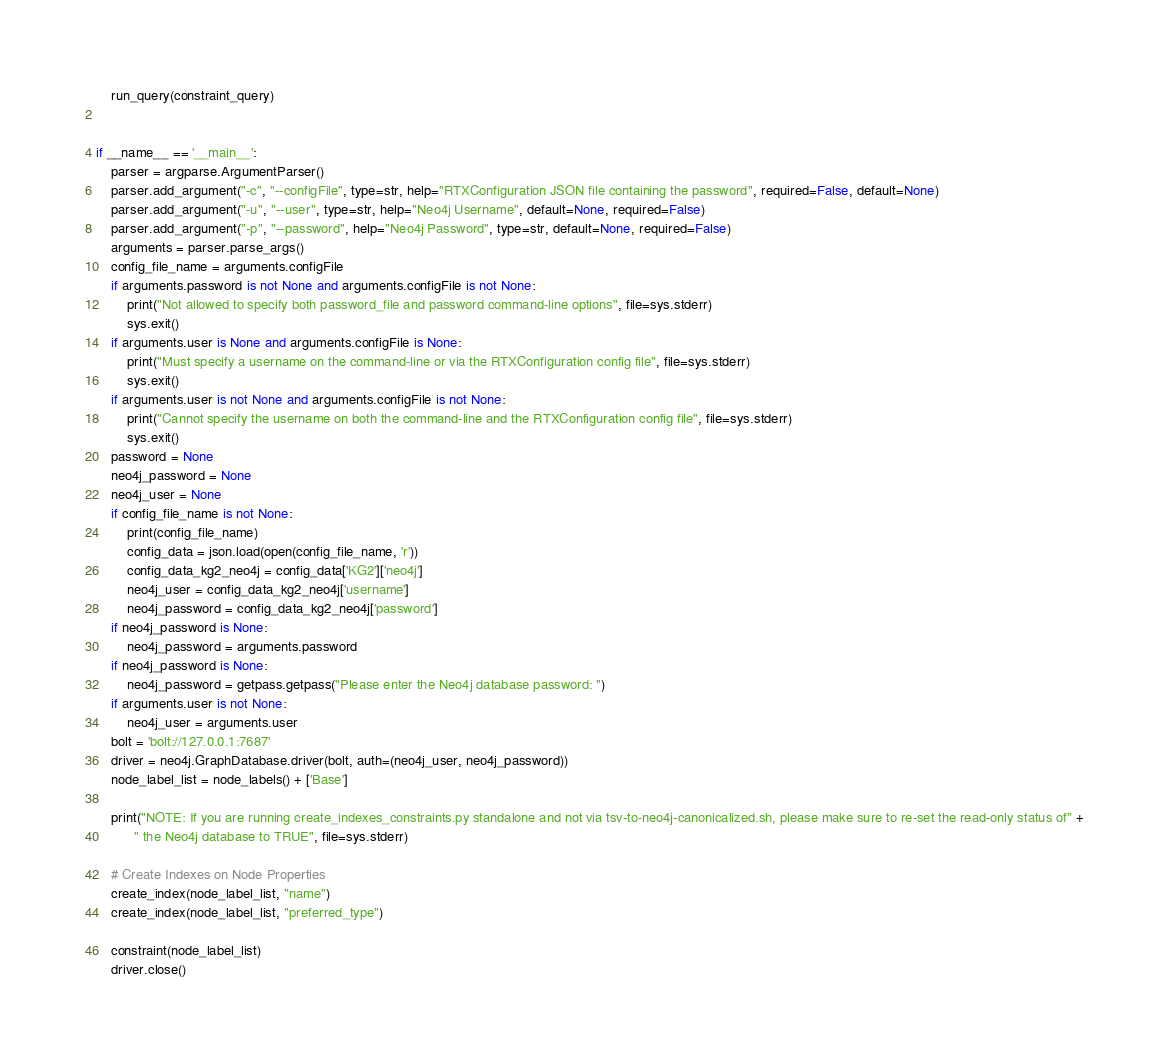<code> <loc_0><loc_0><loc_500><loc_500><_Python_>    run_query(constraint_query)


if __name__ == '__main__':
    parser = argparse.ArgumentParser()
    parser.add_argument("-c", "--configFile", type=str, help="RTXConfiguration JSON file containing the password", required=False, default=None)
    parser.add_argument("-u", "--user", type=str, help="Neo4j Username", default=None, required=False)
    parser.add_argument("-p", "--password", help="Neo4j Password", type=str, default=None, required=False)
    arguments = parser.parse_args()
    config_file_name = arguments.configFile
    if arguments.password is not None and arguments.configFile is not None:
        print("Not allowed to specify both password_file and password command-line options", file=sys.stderr)
        sys.exit()
    if arguments.user is None and arguments.configFile is None:
        print("Must specify a username on the command-line or via the RTXConfiguration config file", file=sys.stderr)
        sys.exit()
    if arguments.user is not None and arguments.configFile is not None:
        print("Cannot specify the username on both the command-line and the RTXConfiguration config file", file=sys.stderr)
        sys.exit()
    password = None
    neo4j_password = None
    neo4j_user = None
    if config_file_name is not None:
        print(config_file_name)
        config_data = json.load(open(config_file_name, 'r'))
        config_data_kg2_neo4j = config_data['KG2']['neo4j']
        neo4j_user = config_data_kg2_neo4j['username']
        neo4j_password = config_data_kg2_neo4j['password']
    if neo4j_password is None:
        neo4j_password = arguments.password
    if neo4j_password is None:
        neo4j_password = getpass.getpass("Please enter the Neo4j database password: ")
    if arguments.user is not None:
        neo4j_user = arguments.user
    bolt = 'bolt://127.0.0.1:7687'
    driver = neo4j.GraphDatabase.driver(bolt, auth=(neo4j_user, neo4j_password))
    node_label_list = node_labels() + ['Base']

    print("NOTE: If you are running create_indexes_constraints.py standalone and not via tsv-to-neo4j-canonicalized.sh, please make sure to re-set the read-only status of" +
          " the Neo4j database to TRUE", file=sys.stderr)

    # Create Indexes on Node Properties
    create_index(node_label_list, "name")
    create_index(node_label_list, "preferred_type")

    constraint(node_label_list)
    driver.close()
</code> 